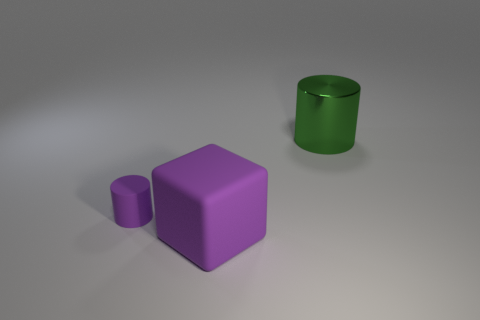Is the number of blocks that are right of the green shiny thing greater than the number of large green metallic things in front of the tiny purple thing?
Provide a succinct answer. No. Is there anything else that is the same color as the metal cylinder?
Your answer should be compact. No. There is a shiny object that is behind the cylinder that is on the left side of the green thing; is there a thing to the left of it?
Provide a succinct answer. Yes. Do the large thing to the right of the big purple thing and the big purple thing have the same shape?
Keep it short and to the point. No. Is the number of small purple cylinders that are on the left side of the green thing less than the number of big objects to the right of the tiny rubber object?
Provide a short and direct response. Yes. What material is the large green object?
Your response must be concise. Metal. There is a big cube; is its color the same as the cylinder in front of the green metal object?
Give a very brief answer. Yes. What number of cylinders are behind the purple cylinder?
Your answer should be very brief. 1. Are there fewer purple cubes that are in front of the small purple matte cylinder than cylinders?
Provide a short and direct response. Yes. What is the color of the rubber cylinder?
Offer a terse response. Purple. 